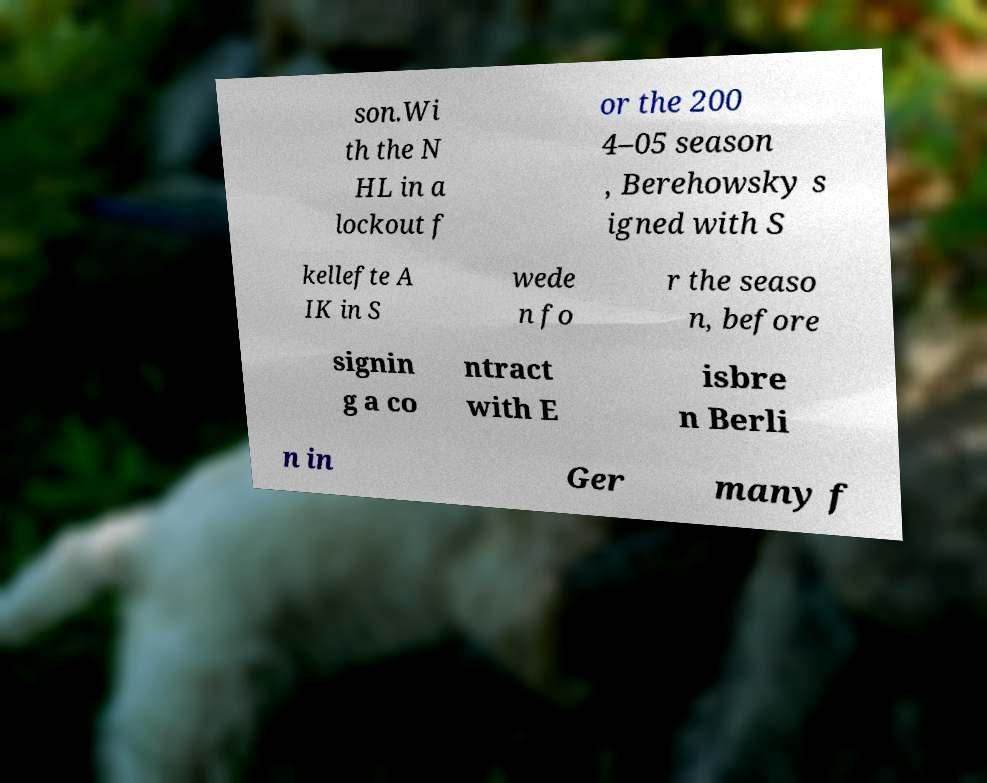Can you read and provide the text displayed in the image?This photo seems to have some interesting text. Can you extract and type it out for me? son.Wi th the N HL in a lockout f or the 200 4–05 season , Berehowsky s igned with S kellefte A IK in S wede n fo r the seaso n, before signin g a co ntract with E isbre n Berli n in Ger many f 